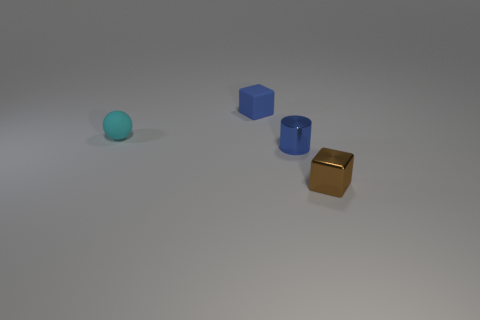Are there any indications about the sizes of these objects relative to each other? Relative to each other, the objects seem to be of similar sizes but different shapes. There's a spherical item, a cube, a cylinder, and a small rectangular box, each with its distinct geometric dimension, suggesting an exercise in understanding shapes and volume. 